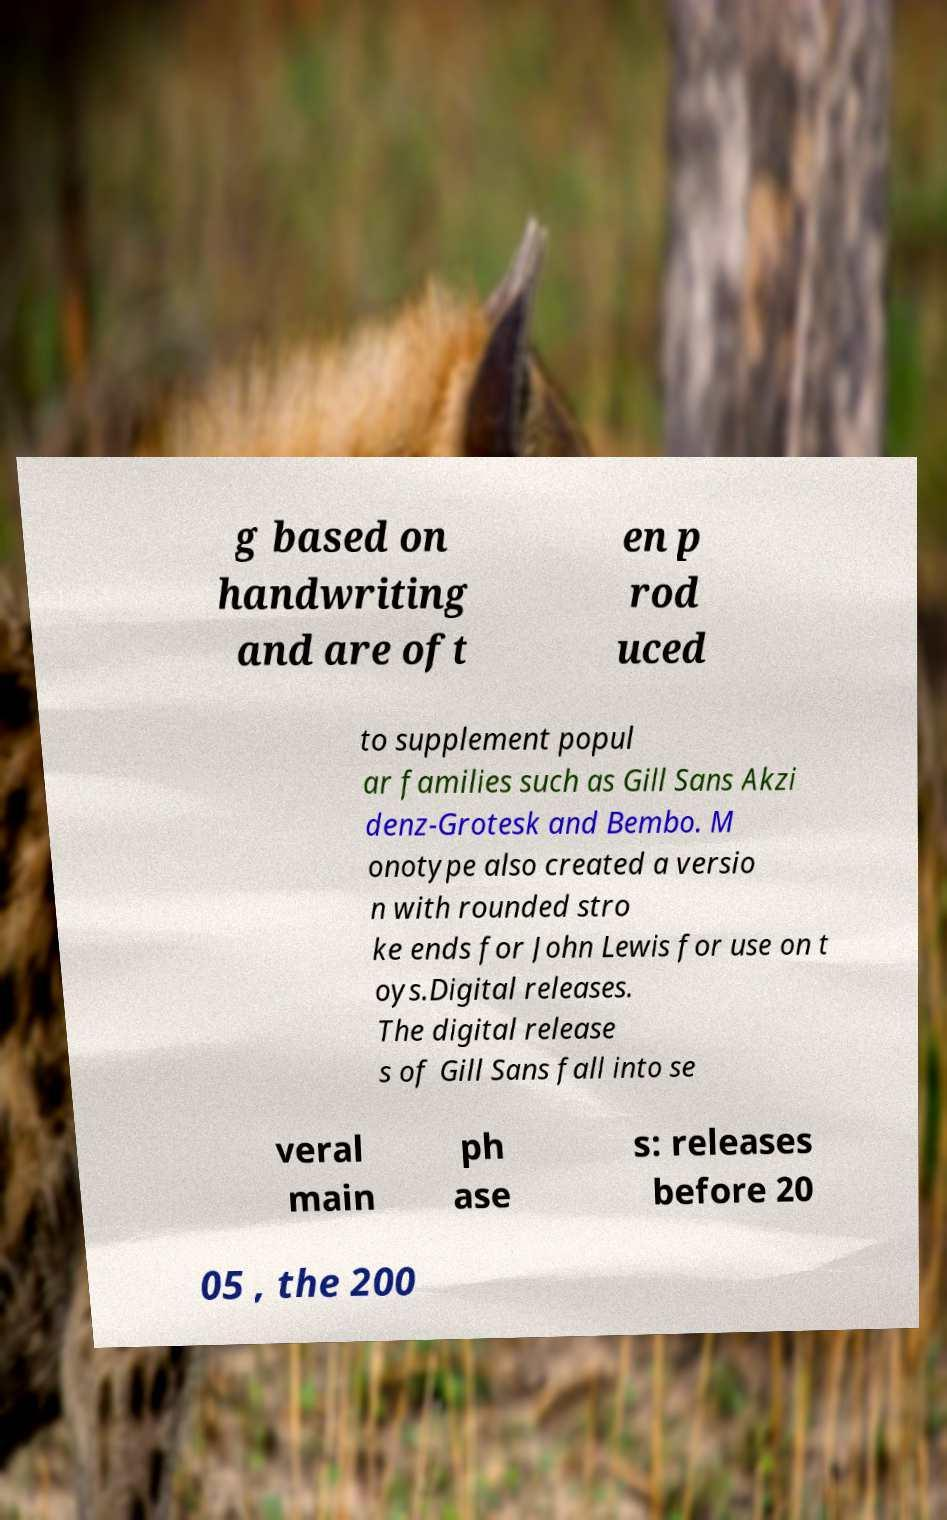Please read and relay the text visible in this image. What does it say? g based on handwriting and are oft en p rod uced to supplement popul ar families such as Gill Sans Akzi denz-Grotesk and Bembo. M onotype also created a versio n with rounded stro ke ends for John Lewis for use on t oys.Digital releases. The digital release s of Gill Sans fall into se veral main ph ase s: releases before 20 05 , the 200 